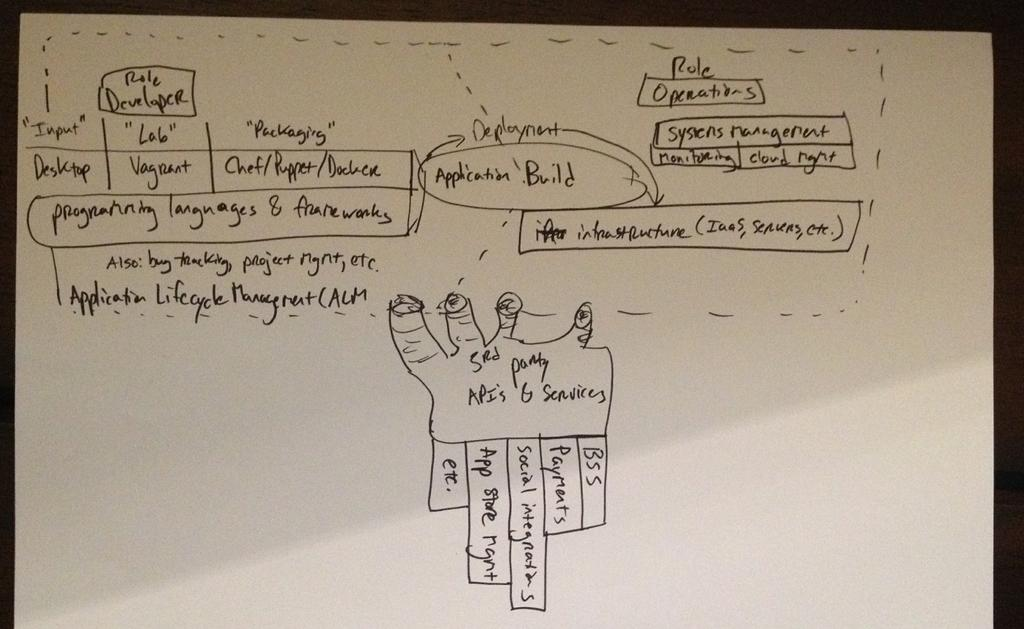What color is the main object in the image? The main object in the image is white. What is written on the white object? There is writing on the white object. How does the butter affect the business during the rainstorm in the image? There is no butter, business, or rainstorm present in the image. 